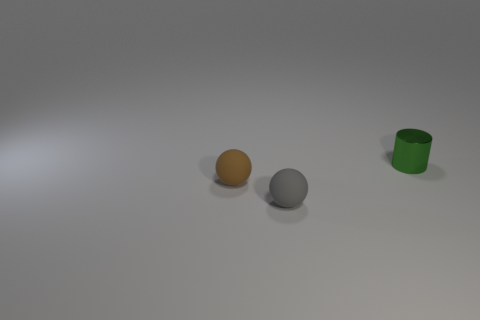Add 2 gray things. How many objects exist? 5 Subtract all brown balls. How many balls are left? 1 Subtract 1 cylinders. How many cylinders are left? 0 Subtract all red cylinders. Subtract all green cubes. How many cylinders are left? 1 Subtract all green balls. How many red cylinders are left? 0 Subtract all small green cylinders. Subtract all large yellow objects. How many objects are left? 2 Add 1 gray spheres. How many gray spheres are left? 2 Add 1 large brown shiny balls. How many large brown shiny balls exist? 1 Subtract 0 blue cylinders. How many objects are left? 3 Subtract all cylinders. How many objects are left? 2 